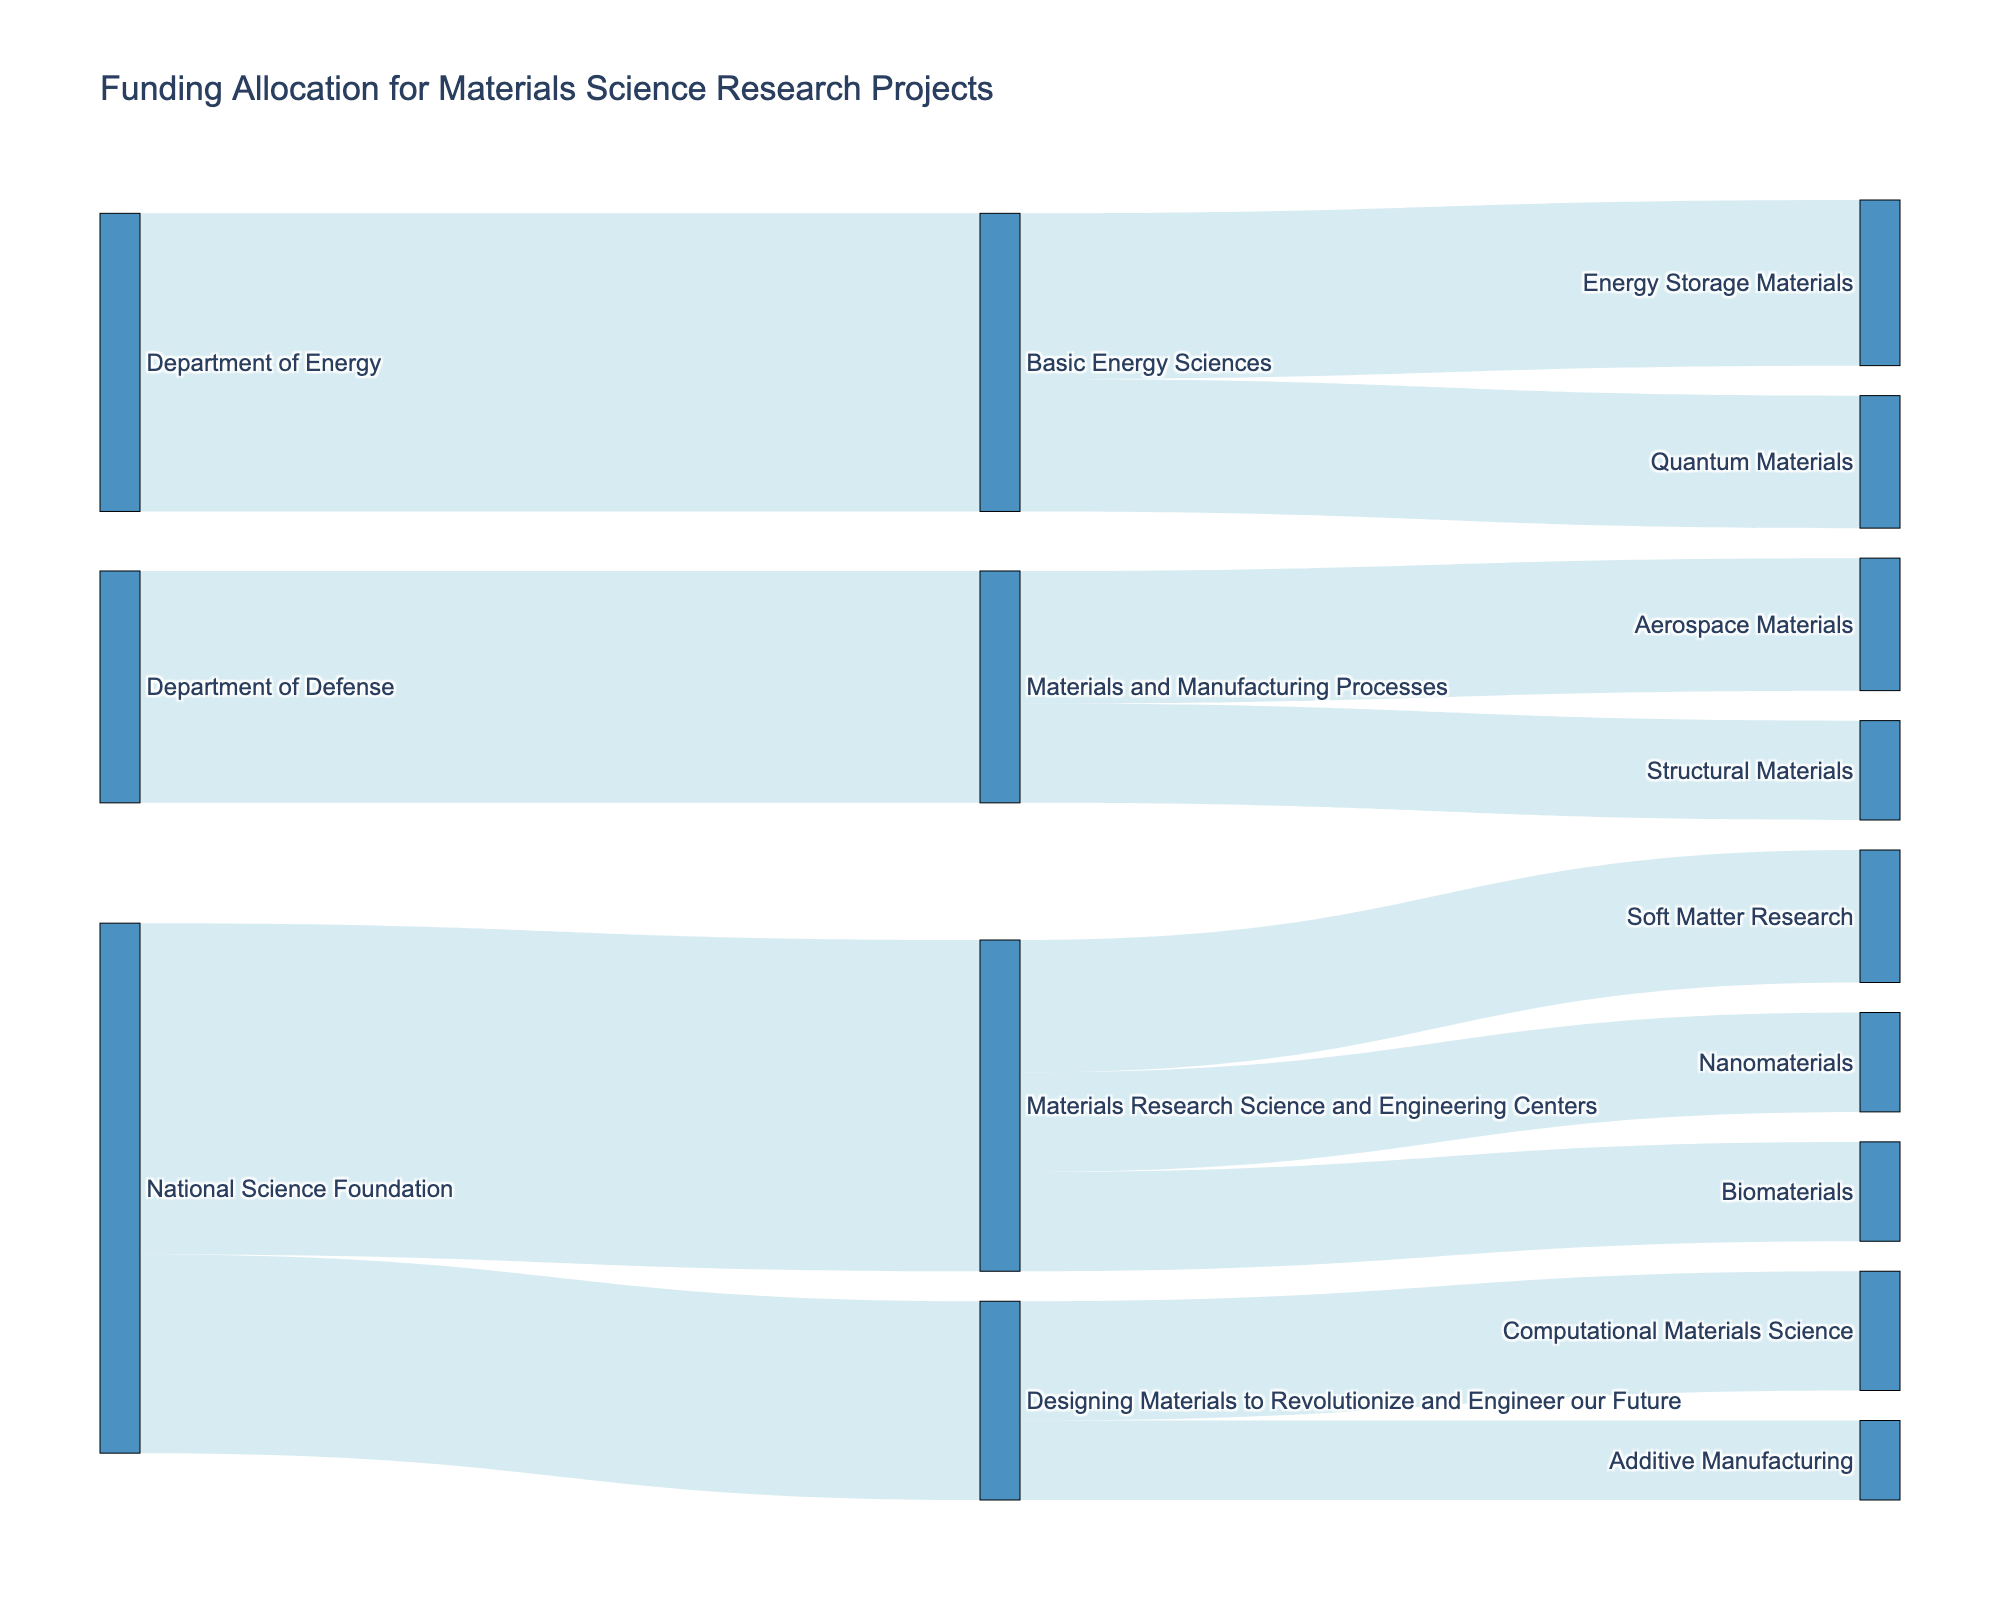What is the title of the Sankey diagram? The title is located at the top of the diagram and provides an overview of what the diagram represents.
Answer: Funding Allocation for Materials Science Research Projects How much funding does the National Science Foundation allocate to Designing Materials to Revolutionize and Engineer our Future? Look at the link from National Science Foundation to Designing Materials to Revolutionize and Engineer our Future. The value is written next to the link.
Answer: 3,000,000 Which organization provides the most funding overall? Add the funding amounts from each organization at the source level. The National Science Foundation provides 8,000,000 (5,000,000 + 3,000,000), Department of Energy provides 4,500,000, and Department of Defense provides 3,500,000.
Answer: National Science Foundation What is the total funding allocated to Materials Research Science and Engineering Centers? Sum the values of all links from Materials Research Science and Engineering Centers to their targets: 2,000,000 + 1,500,000 + 1,500,000.
Answer: 5,000,000 Compare the funding allocated to Energy Storage Materials and Quantum Materials. Which one receives more funding? Look at the links originating from Basic Energy Sciences to both Energy Storage Materials and Quantum Materials. Compare their values: 2,500,000 for Energy Storage Materials and 2,000,000 for Quantum Materials.
Answer: Energy Storage Materials Which research area within Materials Research Science and Engineering Centers receives the least funding? Compare the values of funding allocated to Soft Matter Research, Nanomaterials, and Biomaterials: 2,000,000, 1,500,000, and 1,500,000 respectively. The smallest amount is 1,500,000.
Answer: Nanomaterials and Biomaterials (tie) How much total funding does the Department of Energy allocate to its projects? Sum the values of the links from Department of Energy: 4,500,000 from Basic Energy Sciences.
Answer: 4,500,000 What percentage of the National Science Foundation's total funding is allocated to Materials Research Science and Engineering Centers? National Science Foundation's total funding is 8,000,000. The funding to Materials Research Science and Engineering Centers is 5,000,000. Calculate the percentage: (5,000,000 / 8,000,000) * 100%.
Answer: 62.5% How does the funding for Aerospace Materials compare to Structural Materials? Look at the links from Materials and Manufacturing Processes to Aerospace Materials and Structural Materials. Compare the values: 2,000,000 for Aerospace Materials and 1,500,000 for Structural Materials.
Answer: Aerospace Materials receives more What is the total amount of funding allocated by Basic Energy Sciences to its projects? Add the values of the links from Basic Energy Sciences to its projects: 2,500,000 for Energy Storage Materials and 2,000,000 for Quantum Materials.
Answer: 4,500,000 